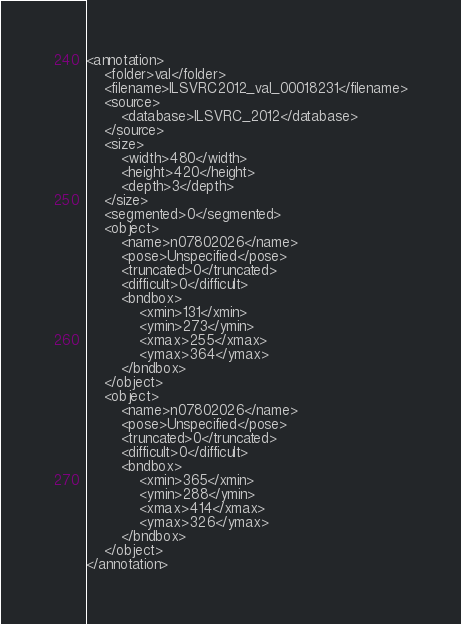<code> <loc_0><loc_0><loc_500><loc_500><_XML_><annotation>
	<folder>val</folder>
	<filename>ILSVRC2012_val_00018231</filename>
	<source>
		<database>ILSVRC_2012</database>
	</source>
	<size>
		<width>480</width>
		<height>420</height>
		<depth>3</depth>
	</size>
	<segmented>0</segmented>
	<object>
		<name>n07802026</name>
		<pose>Unspecified</pose>
		<truncated>0</truncated>
		<difficult>0</difficult>
		<bndbox>
			<xmin>131</xmin>
			<ymin>273</ymin>
			<xmax>255</xmax>
			<ymax>364</ymax>
		</bndbox>
	</object>
	<object>
		<name>n07802026</name>
		<pose>Unspecified</pose>
		<truncated>0</truncated>
		<difficult>0</difficult>
		<bndbox>
			<xmin>365</xmin>
			<ymin>288</ymin>
			<xmax>414</xmax>
			<ymax>326</ymax>
		</bndbox>
	</object>
</annotation></code> 